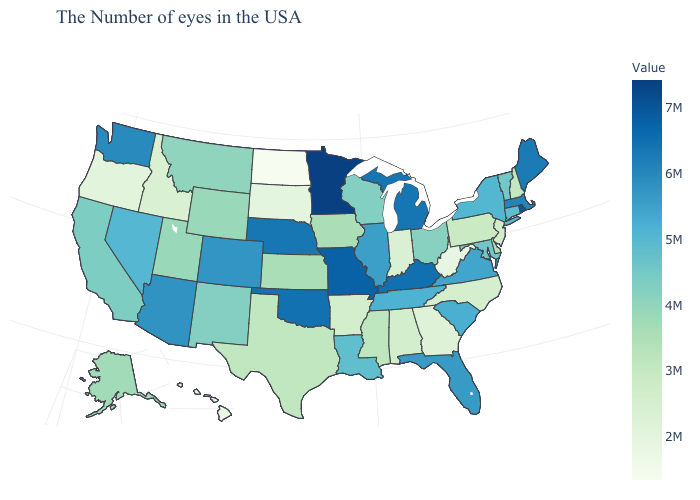Does New Jersey have a higher value than Florida?
Quick response, please. No. Does Indiana have a lower value than Washington?
Answer briefly. Yes. Does the map have missing data?
Quick response, please. No. Which states hav the highest value in the South?
Quick response, please. Kentucky. 